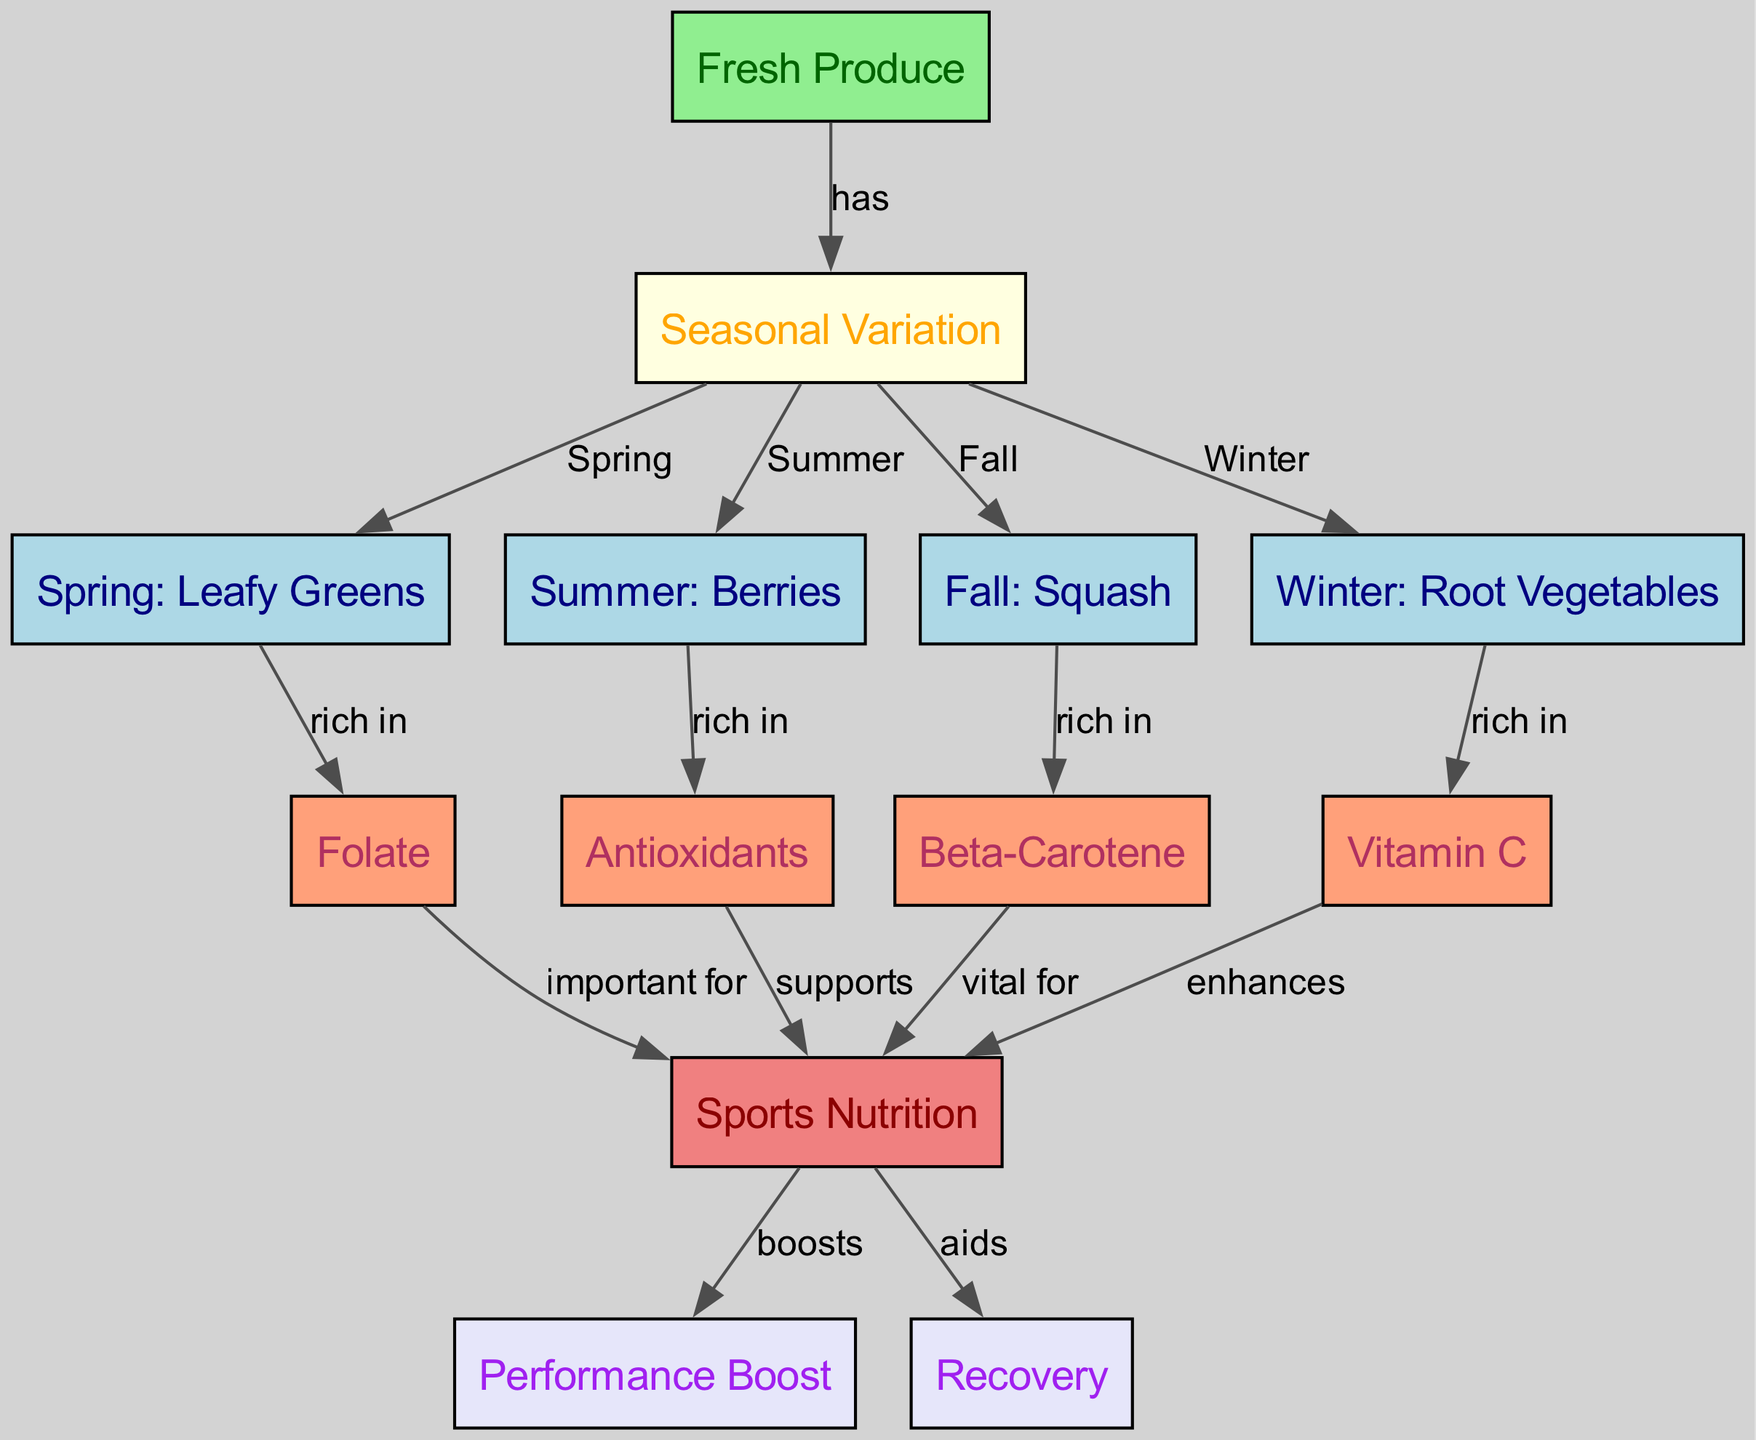What are the seasonal variations represented in the diagram? The diagram shows seasonal variations in four categories: Spring, Summer, Fall, and Winter, each corresponding to specific types of fresh produce.
Answer: Spring, Summer, Fall, Winter Which fresh produce is rich in folate? The diagram indicates that leafy greens in Spring are rich in folate.
Answer: Leafy Greens How many edges are there in the diagram? By counting the connections (edges) between the nodes, I find a total of 12 edges linking the various nodes.
Answer: 12 What does Winter produce contain that enhances sports nutrition? The diagram shows that Winter root vegetables are rich in Vitamin C, which enhances sports nutrition.
Answer: Vitamin C Which type of produce is noted for providing antioxidants? The diagram notes that Summer berries are rich in antioxidants, supporting sports nutrition.
Answer: Berries What nutrients are vital for performance boost according to the diagram? The diagram indicates that beta-carotene from Fall squash is vital for a performance boost in sports nutrition.
Answer: Beta-Carotene What seasonal produce is indicated as supporting recovery? The diagram identifies multiple nodes, but specifically, leafy greens in Spring are important for recovery.
Answer: Leafy Greens Which season's produce has four direct influences on sports nutrition? The diagram shows that Spring produce (leafy greens) has a direct influence on folate, which is important for sports nutrition.
Answer: Spring How does the diagram connect seasonal produce to sports nutrition? The edges in the diagram create pathways from seasonal produce to various nutrients, indicating their importance in enhancing sports nutrition through performance and recovery attributes.
Answer: Seasonal Produce to Sports Nutrition 